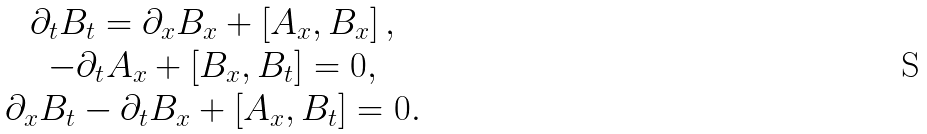Convert formula to latex. <formula><loc_0><loc_0><loc_500><loc_500>\begin{array} { c } \partial _ { t } B _ { t } = \partial _ { x } B _ { x } + \left [ A _ { x } , B _ { x } \right ] , \\ - \partial _ { t } A _ { x } + \left [ B _ { x } , B _ { t } \right ] = 0 , \\ \partial _ { x } B _ { t } - \partial _ { t } B _ { x } + \left [ A _ { x } , B _ { t } \right ] = 0 . \end{array}</formula> 